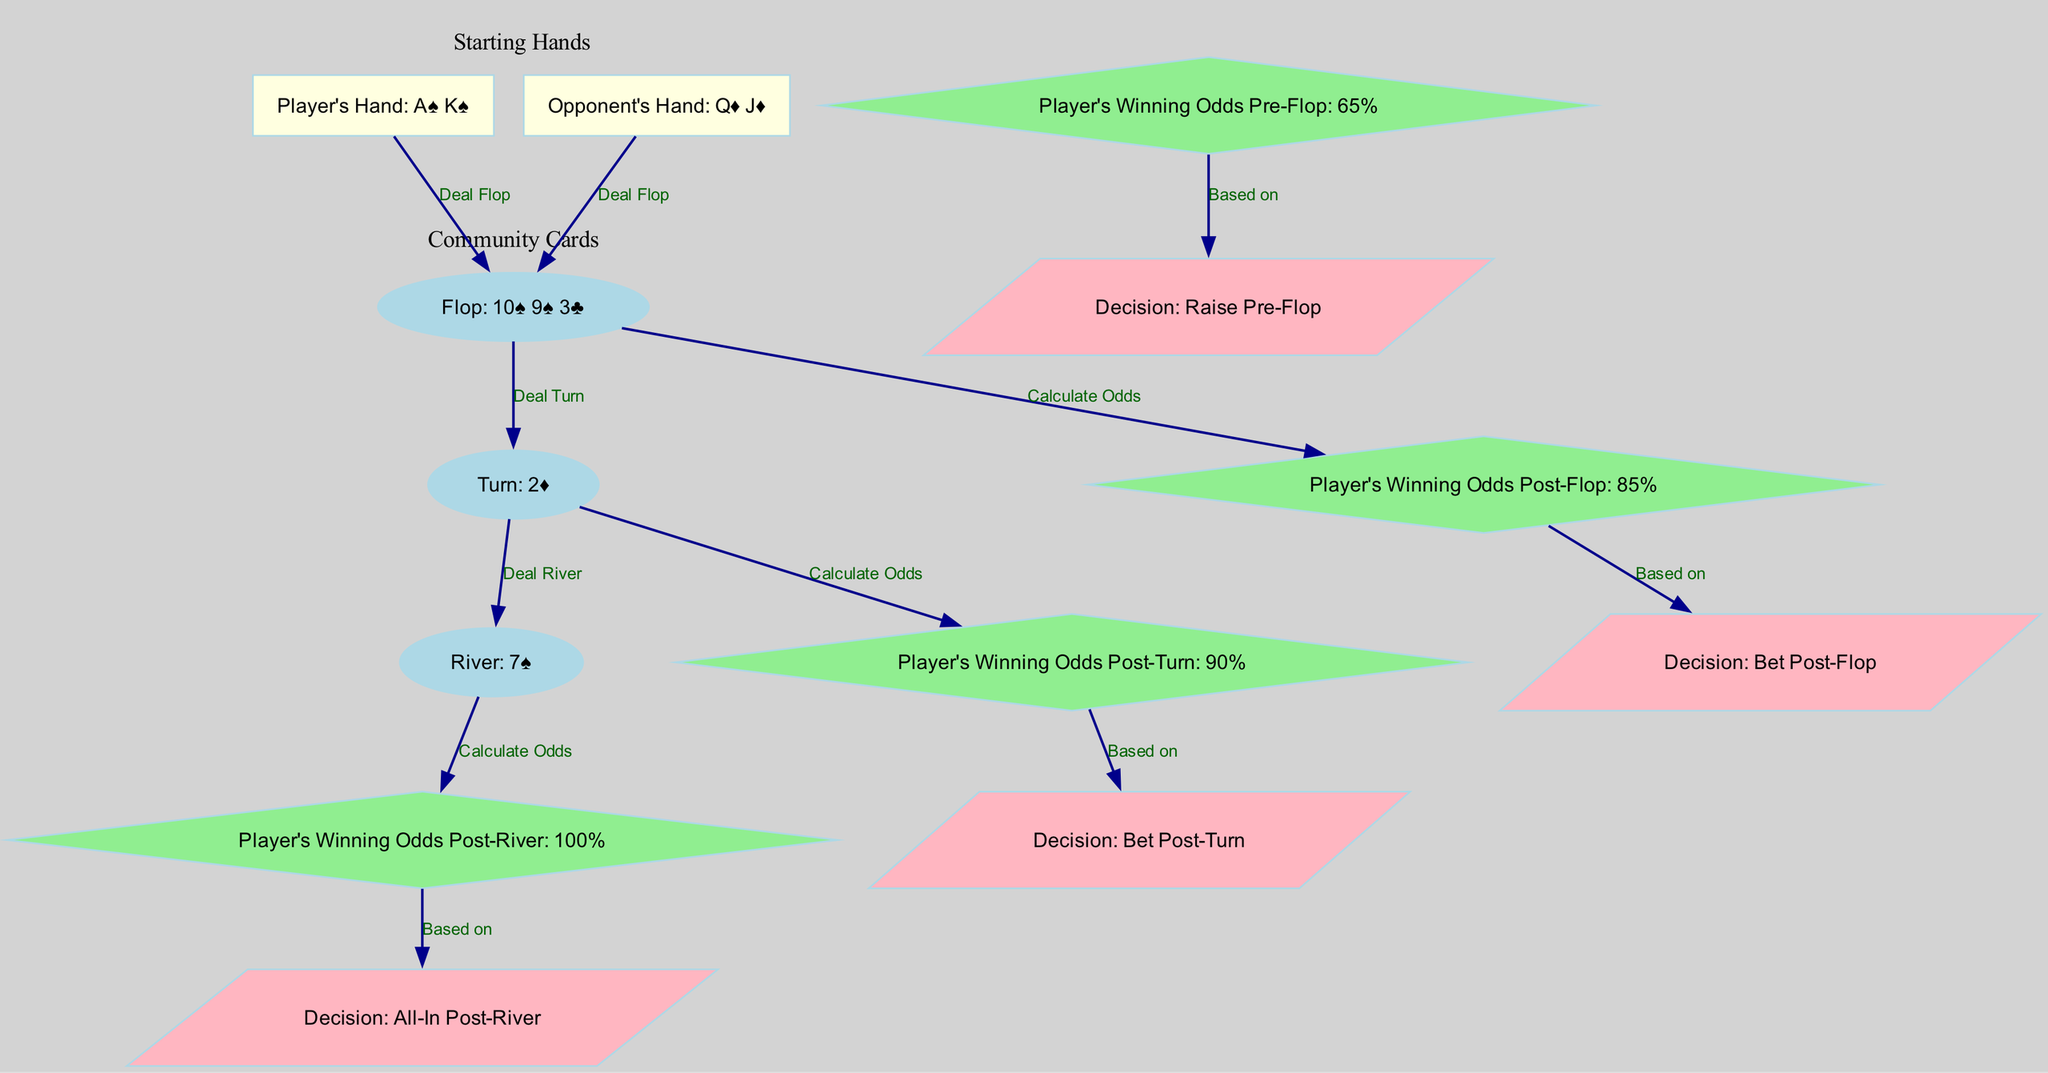What is the player's hand? The node labeled "Player's Hand" indicates that the player's hand is "A♠ K♠." This is directly found in the diagram under the node for the player's hand.
Answer: A♠ K♠ What are the community cards on the flop? The node labeled "Flop" shows "10♠ 9♠ 3♣," which are the community cards revealed at that stage of the game. This information is reflected directly in the diagram.
Answer: 10♠ 9♠ 3♣ What are the player's winning odds pre-flop? The node labeled "Player's Winning Odds Pre-Flop" shows a value of "65%." This can be read directly from the appropriate node in the diagram.
Answer: 65% What decision does the player make post-river? The node labeled "Decision: All-In Post-River" indicates that the player decides to go all-in after the river card. This is shown towards the end of the decision flow in the diagram.
Answer: All-In Post-River How many edges are connecting the probabilities to decisions? By counting the edges that connect nodes labeled with "Probability" to those labeled with "Decision," we find that there are four such edges. This can be confirmed by reviewing the connections in the diagram.
Answer: 4 What are the player's winning odds post-turn? The node labeled "Player's Winning Odds Post-Turn" displays "90%." This information is found in the respective node for post-turn odds in the diagram.
Answer: 90% Which hand does the opponent hold? The node labeled "Opponent's Hand" shows "Q♦ J♦," indicating the cards that the opponent is holding. This is clearly stated in the diagram's nodes.
Answer: Q♦ J♦ What odds calculation leads to the betting decision post-flop? The edge connecting "Flop" to "Probability2" indicates that the player's winning odds are calculated after the flop, leading to the decision to bet post-flop. This is a straightforward trace through the connections in the diagram.
Answer: Odds Calculation Post-Flop What is the turn card dealt after the flop? The node labeled "Turn" shows "2♦," which represents the card dealt after the flop in the sequence of the poker game. This is found directly in the diagram.
Answer: 2♦ 